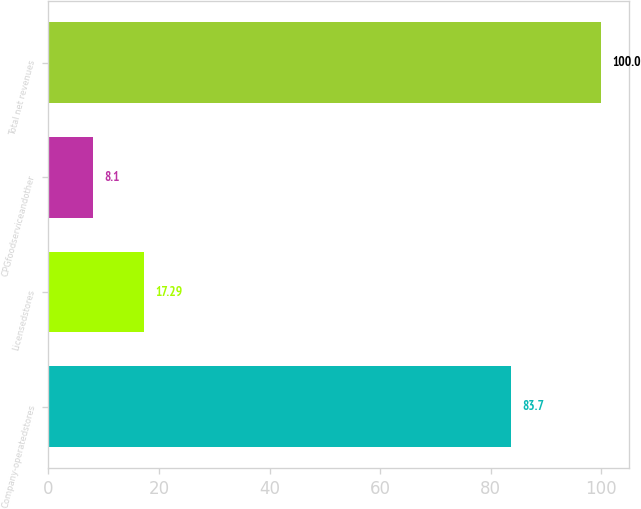Convert chart. <chart><loc_0><loc_0><loc_500><loc_500><bar_chart><fcel>Company-operatedstores<fcel>Licensedstores<fcel>CPGfoodserviceandother<fcel>Total net revenues<nl><fcel>83.7<fcel>17.29<fcel>8.1<fcel>100<nl></chart> 